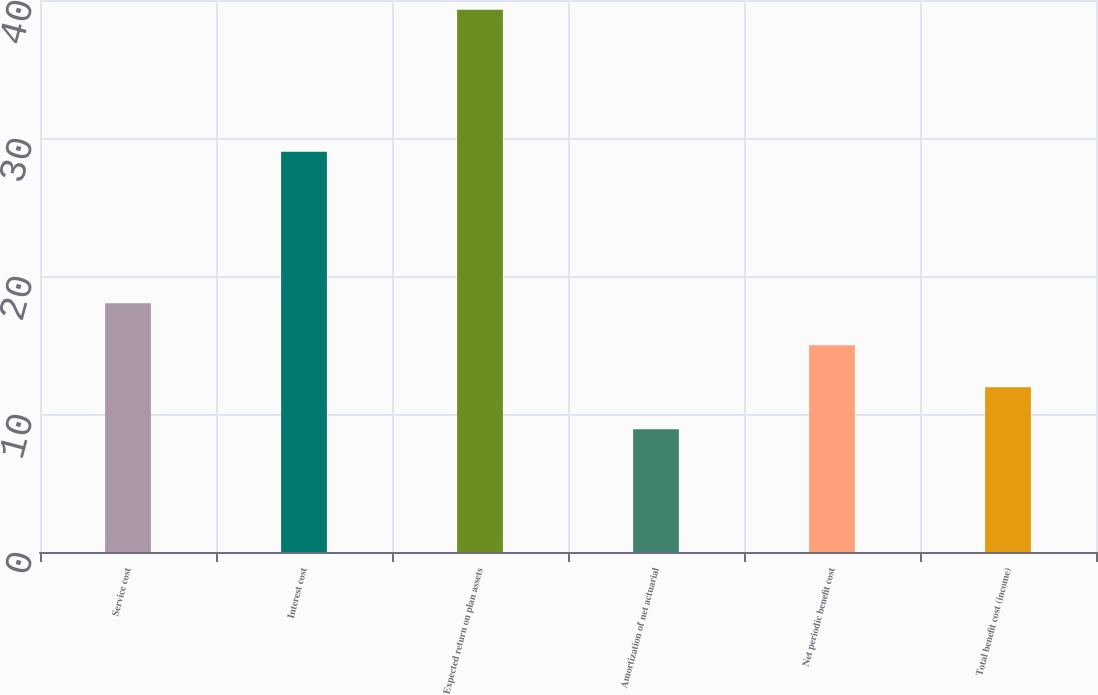<chart> <loc_0><loc_0><loc_500><loc_500><bar_chart><fcel>Service cost<fcel>Interest cost<fcel>Expected return on plan assets<fcel>Amortization of net actuarial<fcel>Net periodic benefit cost<fcel>Total benefit cost (income)<nl><fcel>18.02<fcel>29<fcel>39.3<fcel>8.9<fcel>14.98<fcel>11.94<nl></chart> 